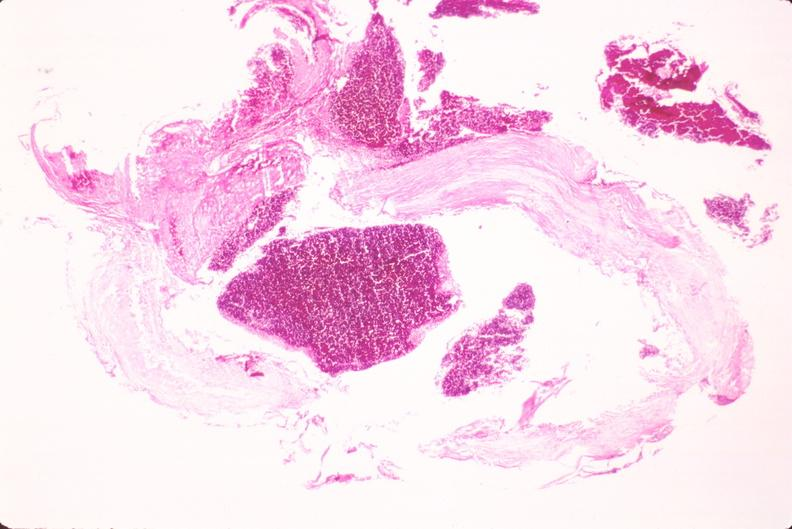s cardiovascular present?
Answer the question using a single word or phrase. Yes 